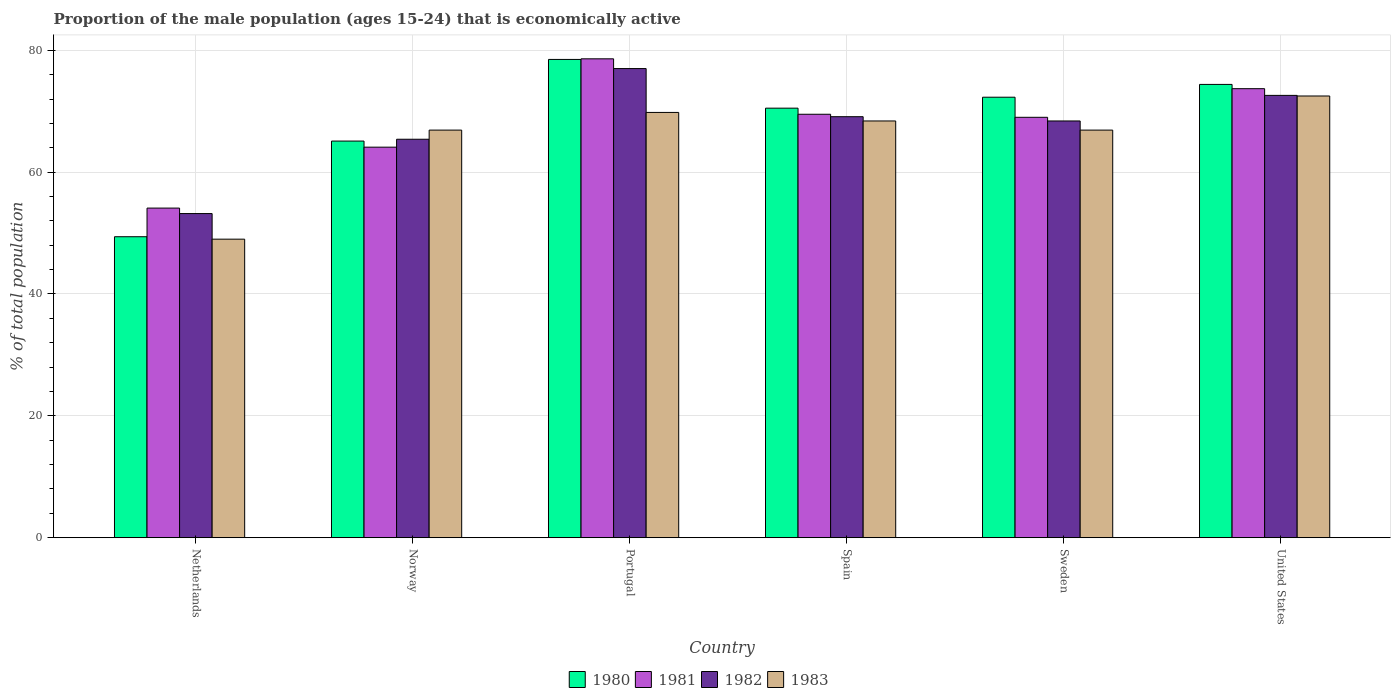How many bars are there on the 1st tick from the right?
Make the answer very short. 4. What is the label of the 3rd group of bars from the left?
Offer a very short reply. Portugal. In how many cases, is the number of bars for a given country not equal to the number of legend labels?
Ensure brevity in your answer.  0. What is the proportion of the male population that is economically active in 1980 in Sweden?
Ensure brevity in your answer.  72.3. Across all countries, what is the maximum proportion of the male population that is economically active in 1982?
Make the answer very short. 77. Across all countries, what is the minimum proportion of the male population that is economically active in 1983?
Your answer should be very brief. 49. In which country was the proportion of the male population that is economically active in 1982 maximum?
Your answer should be compact. Portugal. What is the total proportion of the male population that is economically active in 1980 in the graph?
Your answer should be compact. 410.2. What is the difference between the proportion of the male population that is economically active in 1983 in Spain and that in United States?
Your answer should be compact. -4.1. What is the difference between the proportion of the male population that is economically active in 1980 in Sweden and the proportion of the male population that is economically active in 1982 in Norway?
Your answer should be very brief. 6.9. What is the average proportion of the male population that is economically active in 1982 per country?
Ensure brevity in your answer.  67.62. What is the difference between the proportion of the male population that is economically active of/in 1983 and proportion of the male population that is economically active of/in 1981 in Netherlands?
Make the answer very short. -5.1. What is the ratio of the proportion of the male population that is economically active in 1981 in Norway to that in Sweden?
Offer a terse response. 0.93. What is the difference between the highest and the second highest proportion of the male population that is economically active in 1980?
Your answer should be compact. -2.1. What is the difference between the highest and the lowest proportion of the male population that is economically active in 1983?
Your answer should be very brief. 23.5. In how many countries, is the proportion of the male population that is economically active in 1980 greater than the average proportion of the male population that is economically active in 1980 taken over all countries?
Ensure brevity in your answer.  4. Is the sum of the proportion of the male population that is economically active in 1981 in Norway and Spain greater than the maximum proportion of the male population that is economically active in 1982 across all countries?
Your response must be concise. Yes. Is it the case that in every country, the sum of the proportion of the male population that is economically active in 1981 and proportion of the male population that is economically active in 1982 is greater than the sum of proportion of the male population that is economically active in 1980 and proportion of the male population that is economically active in 1983?
Provide a short and direct response. No. What does the 1st bar from the right in United States represents?
Your answer should be very brief. 1983. Is it the case that in every country, the sum of the proportion of the male population that is economically active in 1982 and proportion of the male population that is economically active in 1983 is greater than the proportion of the male population that is economically active in 1980?
Your answer should be very brief. Yes. How many bars are there?
Your answer should be compact. 24. Are all the bars in the graph horizontal?
Your answer should be very brief. No. What is the difference between two consecutive major ticks on the Y-axis?
Your answer should be compact. 20. Are the values on the major ticks of Y-axis written in scientific E-notation?
Make the answer very short. No. Does the graph contain any zero values?
Ensure brevity in your answer.  No. Does the graph contain grids?
Ensure brevity in your answer.  Yes. Where does the legend appear in the graph?
Offer a very short reply. Bottom center. How many legend labels are there?
Make the answer very short. 4. What is the title of the graph?
Give a very brief answer. Proportion of the male population (ages 15-24) that is economically active. What is the label or title of the Y-axis?
Your answer should be very brief. % of total population. What is the % of total population of 1980 in Netherlands?
Your answer should be compact. 49.4. What is the % of total population in 1981 in Netherlands?
Ensure brevity in your answer.  54.1. What is the % of total population in 1982 in Netherlands?
Give a very brief answer. 53.2. What is the % of total population of 1980 in Norway?
Ensure brevity in your answer.  65.1. What is the % of total population of 1981 in Norway?
Your response must be concise. 64.1. What is the % of total population in 1982 in Norway?
Your response must be concise. 65.4. What is the % of total population in 1983 in Norway?
Your answer should be compact. 66.9. What is the % of total population of 1980 in Portugal?
Your response must be concise. 78.5. What is the % of total population of 1981 in Portugal?
Offer a terse response. 78.6. What is the % of total population of 1983 in Portugal?
Offer a terse response. 69.8. What is the % of total population of 1980 in Spain?
Your answer should be compact. 70.5. What is the % of total population of 1981 in Spain?
Your answer should be very brief. 69.5. What is the % of total population of 1982 in Spain?
Offer a very short reply. 69.1. What is the % of total population of 1983 in Spain?
Offer a very short reply. 68.4. What is the % of total population of 1980 in Sweden?
Provide a succinct answer. 72.3. What is the % of total population of 1982 in Sweden?
Give a very brief answer. 68.4. What is the % of total population in 1983 in Sweden?
Offer a terse response. 66.9. What is the % of total population in 1980 in United States?
Make the answer very short. 74.4. What is the % of total population of 1981 in United States?
Make the answer very short. 73.7. What is the % of total population of 1982 in United States?
Make the answer very short. 72.6. What is the % of total population of 1983 in United States?
Your response must be concise. 72.5. Across all countries, what is the maximum % of total population in 1980?
Your answer should be very brief. 78.5. Across all countries, what is the maximum % of total population of 1981?
Offer a terse response. 78.6. Across all countries, what is the maximum % of total population in 1983?
Your answer should be compact. 72.5. Across all countries, what is the minimum % of total population in 1980?
Your answer should be very brief. 49.4. Across all countries, what is the minimum % of total population in 1981?
Your answer should be compact. 54.1. Across all countries, what is the minimum % of total population in 1982?
Your answer should be very brief. 53.2. Across all countries, what is the minimum % of total population in 1983?
Provide a succinct answer. 49. What is the total % of total population of 1980 in the graph?
Offer a terse response. 410.2. What is the total % of total population in 1981 in the graph?
Provide a succinct answer. 409. What is the total % of total population in 1982 in the graph?
Provide a succinct answer. 405.7. What is the total % of total population in 1983 in the graph?
Your answer should be very brief. 393.5. What is the difference between the % of total population in 1980 in Netherlands and that in Norway?
Provide a succinct answer. -15.7. What is the difference between the % of total population in 1981 in Netherlands and that in Norway?
Your response must be concise. -10. What is the difference between the % of total population of 1982 in Netherlands and that in Norway?
Your answer should be compact. -12.2. What is the difference between the % of total population of 1983 in Netherlands and that in Norway?
Your answer should be very brief. -17.9. What is the difference between the % of total population of 1980 in Netherlands and that in Portugal?
Make the answer very short. -29.1. What is the difference between the % of total population of 1981 in Netherlands and that in Portugal?
Keep it short and to the point. -24.5. What is the difference between the % of total population of 1982 in Netherlands and that in Portugal?
Make the answer very short. -23.8. What is the difference between the % of total population in 1983 in Netherlands and that in Portugal?
Give a very brief answer. -20.8. What is the difference between the % of total population of 1980 in Netherlands and that in Spain?
Make the answer very short. -21.1. What is the difference between the % of total population in 1981 in Netherlands and that in Spain?
Ensure brevity in your answer.  -15.4. What is the difference between the % of total population in 1982 in Netherlands and that in Spain?
Offer a terse response. -15.9. What is the difference between the % of total population in 1983 in Netherlands and that in Spain?
Give a very brief answer. -19.4. What is the difference between the % of total population of 1980 in Netherlands and that in Sweden?
Give a very brief answer. -22.9. What is the difference between the % of total population of 1981 in Netherlands and that in Sweden?
Your answer should be compact. -14.9. What is the difference between the % of total population in 1982 in Netherlands and that in Sweden?
Give a very brief answer. -15.2. What is the difference between the % of total population of 1983 in Netherlands and that in Sweden?
Your answer should be very brief. -17.9. What is the difference between the % of total population of 1980 in Netherlands and that in United States?
Your answer should be very brief. -25. What is the difference between the % of total population of 1981 in Netherlands and that in United States?
Your answer should be compact. -19.6. What is the difference between the % of total population of 1982 in Netherlands and that in United States?
Give a very brief answer. -19.4. What is the difference between the % of total population in 1983 in Netherlands and that in United States?
Keep it short and to the point. -23.5. What is the difference between the % of total population of 1981 in Norway and that in Portugal?
Your answer should be compact. -14.5. What is the difference between the % of total population in 1980 in Norway and that in Spain?
Your answer should be very brief. -5.4. What is the difference between the % of total population of 1981 in Norway and that in Spain?
Provide a short and direct response. -5.4. What is the difference between the % of total population of 1982 in Norway and that in Spain?
Ensure brevity in your answer.  -3.7. What is the difference between the % of total population of 1983 in Norway and that in Spain?
Offer a very short reply. -1.5. What is the difference between the % of total population in 1981 in Norway and that in Sweden?
Your answer should be compact. -4.9. What is the difference between the % of total population in 1980 in Norway and that in United States?
Provide a succinct answer. -9.3. What is the difference between the % of total population in 1983 in Norway and that in United States?
Offer a very short reply. -5.6. What is the difference between the % of total population of 1981 in Portugal and that in Spain?
Your answer should be very brief. 9.1. What is the difference between the % of total population of 1983 in Portugal and that in Spain?
Your answer should be compact. 1.4. What is the difference between the % of total population of 1981 in Portugal and that in Sweden?
Make the answer very short. 9.6. What is the difference between the % of total population of 1982 in Portugal and that in Sweden?
Give a very brief answer. 8.6. What is the difference between the % of total population in 1980 in Portugal and that in United States?
Your answer should be very brief. 4.1. What is the difference between the % of total population of 1981 in Portugal and that in United States?
Make the answer very short. 4.9. What is the difference between the % of total population in 1982 in Portugal and that in United States?
Keep it short and to the point. 4.4. What is the difference between the % of total population in 1980 in Spain and that in Sweden?
Your answer should be compact. -1.8. What is the difference between the % of total population in 1983 in Spain and that in Sweden?
Your answer should be compact. 1.5. What is the difference between the % of total population in 1982 in Sweden and that in United States?
Give a very brief answer. -4.2. What is the difference between the % of total population of 1983 in Sweden and that in United States?
Provide a short and direct response. -5.6. What is the difference between the % of total population of 1980 in Netherlands and the % of total population of 1981 in Norway?
Give a very brief answer. -14.7. What is the difference between the % of total population of 1980 in Netherlands and the % of total population of 1983 in Norway?
Your response must be concise. -17.5. What is the difference between the % of total population of 1981 in Netherlands and the % of total population of 1983 in Norway?
Your answer should be compact. -12.8. What is the difference between the % of total population in 1982 in Netherlands and the % of total population in 1983 in Norway?
Provide a succinct answer. -13.7. What is the difference between the % of total population in 1980 in Netherlands and the % of total population in 1981 in Portugal?
Your answer should be very brief. -29.2. What is the difference between the % of total population of 1980 in Netherlands and the % of total population of 1982 in Portugal?
Offer a very short reply. -27.6. What is the difference between the % of total population in 1980 in Netherlands and the % of total population in 1983 in Portugal?
Provide a short and direct response. -20.4. What is the difference between the % of total population of 1981 in Netherlands and the % of total population of 1982 in Portugal?
Offer a terse response. -22.9. What is the difference between the % of total population of 1981 in Netherlands and the % of total population of 1983 in Portugal?
Give a very brief answer. -15.7. What is the difference between the % of total population in 1982 in Netherlands and the % of total population in 1983 in Portugal?
Give a very brief answer. -16.6. What is the difference between the % of total population in 1980 in Netherlands and the % of total population in 1981 in Spain?
Your answer should be compact. -20.1. What is the difference between the % of total population in 1980 in Netherlands and the % of total population in 1982 in Spain?
Your answer should be compact. -19.7. What is the difference between the % of total population of 1981 in Netherlands and the % of total population of 1982 in Spain?
Keep it short and to the point. -15. What is the difference between the % of total population of 1981 in Netherlands and the % of total population of 1983 in Spain?
Offer a very short reply. -14.3. What is the difference between the % of total population of 1982 in Netherlands and the % of total population of 1983 in Spain?
Provide a succinct answer. -15.2. What is the difference between the % of total population in 1980 in Netherlands and the % of total population in 1981 in Sweden?
Give a very brief answer. -19.6. What is the difference between the % of total population of 1980 in Netherlands and the % of total population of 1982 in Sweden?
Offer a very short reply. -19. What is the difference between the % of total population in 1980 in Netherlands and the % of total population in 1983 in Sweden?
Make the answer very short. -17.5. What is the difference between the % of total population of 1981 in Netherlands and the % of total population of 1982 in Sweden?
Your answer should be very brief. -14.3. What is the difference between the % of total population of 1981 in Netherlands and the % of total population of 1983 in Sweden?
Give a very brief answer. -12.8. What is the difference between the % of total population of 1982 in Netherlands and the % of total population of 1983 in Sweden?
Give a very brief answer. -13.7. What is the difference between the % of total population of 1980 in Netherlands and the % of total population of 1981 in United States?
Provide a succinct answer. -24.3. What is the difference between the % of total population of 1980 in Netherlands and the % of total population of 1982 in United States?
Provide a short and direct response. -23.2. What is the difference between the % of total population of 1980 in Netherlands and the % of total population of 1983 in United States?
Keep it short and to the point. -23.1. What is the difference between the % of total population of 1981 in Netherlands and the % of total population of 1982 in United States?
Provide a succinct answer. -18.5. What is the difference between the % of total population of 1981 in Netherlands and the % of total population of 1983 in United States?
Offer a very short reply. -18.4. What is the difference between the % of total population of 1982 in Netherlands and the % of total population of 1983 in United States?
Offer a very short reply. -19.3. What is the difference between the % of total population of 1980 in Norway and the % of total population of 1982 in Portugal?
Offer a terse response. -11.9. What is the difference between the % of total population of 1980 in Norway and the % of total population of 1983 in Portugal?
Your answer should be compact. -4.7. What is the difference between the % of total population of 1981 in Norway and the % of total population of 1982 in Portugal?
Offer a terse response. -12.9. What is the difference between the % of total population in 1980 in Norway and the % of total population in 1982 in Spain?
Your response must be concise. -4. What is the difference between the % of total population in 1980 in Norway and the % of total population in 1983 in Spain?
Ensure brevity in your answer.  -3.3. What is the difference between the % of total population in 1981 in Norway and the % of total population in 1983 in Spain?
Offer a terse response. -4.3. What is the difference between the % of total population in 1982 in Norway and the % of total population in 1983 in Spain?
Ensure brevity in your answer.  -3. What is the difference between the % of total population in 1981 in Norway and the % of total population in 1982 in Sweden?
Keep it short and to the point. -4.3. What is the difference between the % of total population of 1981 in Norway and the % of total population of 1983 in Sweden?
Your answer should be very brief. -2.8. What is the difference between the % of total population in 1980 in Norway and the % of total population in 1981 in United States?
Your answer should be very brief. -8.6. What is the difference between the % of total population in 1980 in Norway and the % of total population in 1983 in United States?
Ensure brevity in your answer.  -7.4. What is the difference between the % of total population of 1982 in Norway and the % of total population of 1983 in United States?
Give a very brief answer. -7.1. What is the difference between the % of total population of 1980 in Portugal and the % of total population of 1981 in Spain?
Provide a succinct answer. 9. What is the difference between the % of total population of 1980 in Portugal and the % of total population of 1982 in Spain?
Provide a succinct answer. 9.4. What is the difference between the % of total population of 1981 in Portugal and the % of total population of 1982 in Spain?
Your answer should be very brief. 9.5. What is the difference between the % of total population of 1980 in Portugal and the % of total population of 1983 in Sweden?
Make the answer very short. 11.6. What is the difference between the % of total population of 1981 in Portugal and the % of total population of 1983 in Sweden?
Offer a terse response. 11.7. What is the difference between the % of total population in 1980 in Portugal and the % of total population in 1981 in United States?
Ensure brevity in your answer.  4.8. What is the difference between the % of total population of 1980 in Portugal and the % of total population of 1982 in United States?
Give a very brief answer. 5.9. What is the difference between the % of total population of 1980 in Portugal and the % of total population of 1983 in United States?
Give a very brief answer. 6. What is the difference between the % of total population of 1981 in Portugal and the % of total population of 1982 in United States?
Provide a short and direct response. 6. What is the difference between the % of total population of 1981 in Portugal and the % of total population of 1983 in United States?
Offer a very short reply. 6.1. What is the difference between the % of total population of 1980 in Spain and the % of total population of 1983 in Sweden?
Your response must be concise. 3.6. What is the difference between the % of total population in 1981 in Spain and the % of total population in 1982 in Sweden?
Make the answer very short. 1.1. What is the difference between the % of total population in 1980 in Spain and the % of total population in 1983 in United States?
Offer a terse response. -2. What is the difference between the % of total population in 1980 in Sweden and the % of total population in 1982 in United States?
Your answer should be very brief. -0.3. What is the difference between the % of total population of 1980 in Sweden and the % of total population of 1983 in United States?
Your response must be concise. -0.2. What is the difference between the % of total population of 1981 in Sweden and the % of total population of 1982 in United States?
Offer a terse response. -3.6. What is the average % of total population in 1980 per country?
Keep it short and to the point. 68.37. What is the average % of total population of 1981 per country?
Your answer should be very brief. 68.17. What is the average % of total population in 1982 per country?
Keep it short and to the point. 67.62. What is the average % of total population in 1983 per country?
Offer a very short reply. 65.58. What is the difference between the % of total population of 1980 and % of total population of 1982 in Netherlands?
Offer a terse response. -3.8. What is the difference between the % of total population in 1982 and % of total population in 1983 in Netherlands?
Offer a terse response. 4.2. What is the difference between the % of total population of 1980 and % of total population of 1981 in Norway?
Keep it short and to the point. 1. What is the difference between the % of total population in 1980 and % of total population in 1983 in Norway?
Provide a succinct answer. -1.8. What is the difference between the % of total population in 1981 and % of total population in 1983 in Norway?
Offer a terse response. -2.8. What is the difference between the % of total population of 1982 and % of total population of 1983 in Norway?
Provide a succinct answer. -1.5. What is the difference between the % of total population of 1980 and % of total population of 1981 in Portugal?
Your answer should be compact. -0.1. What is the difference between the % of total population in 1980 and % of total population in 1982 in Portugal?
Offer a very short reply. 1.5. What is the difference between the % of total population of 1981 and % of total population of 1982 in Portugal?
Provide a short and direct response. 1.6. What is the difference between the % of total population in 1981 and % of total population in 1983 in Portugal?
Make the answer very short. 8.8. What is the difference between the % of total population in 1982 and % of total population in 1983 in Portugal?
Provide a short and direct response. 7.2. What is the difference between the % of total population in 1980 and % of total population in 1982 in Spain?
Your answer should be compact. 1.4. What is the difference between the % of total population of 1980 and % of total population of 1983 in Spain?
Make the answer very short. 2.1. What is the difference between the % of total population of 1981 and % of total population of 1982 in Spain?
Provide a short and direct response. 0.4. What is the difference between the % of total population of 1982 and % of total population of 1983 in Spain?
Provide a succinct answer. 0.7. What is the difference between the % of total population of 1980 and % of total population of 1981 in Sweden?
Ensure brevity in your answer.  3.3. What is the difference between the % of total population in 1980 and % of total population in 1982 in Sweden?
Your answer should be very brief. 3.9. What is the difference between the % of total population in 1981 and % of total population in 1982 in United States?
Your answer should be very brief. 1.1. What is the ratio of the % of total population of 1980 in Netherlands to that in Norway?
Make the answer very short. 0.76. What is the ratio of the % of total population of 1981 in Netherlands to that in Norway?
Give a very brief answer. 0.84. What is the ratio of the % of total population in 1982 in Netherlands to that in Norway?
Keep it short and to the point. 0.81. What is the ratio of the % of total population in 1983 in Netherlands to that in Norway?
Your answer should be very brief. 0.73. What is the ratio of the % of total population of 1980 in Netherlands to that in Portugal?
Give a very brief answer. 0.63. What is the ratio of the % of total population of 1981 in Netherlands to that in Portugal?
Your response must be concise. 0.69. What is the ratio of the % of total population in 1982 in Netherlands to that in Portugal?
Ensure brevity in your answer.  0.69. What is the ratio of the % of total population in 1983 in Netherlands to that in Portugal?
Your response must be concise. 0.7. What is the ratio of the % of total population in 1980 in Netherlands to that in Spain?
Provide a short and direct response. 0.7. What is the ratio of the % of total population in 1981 in Netherlands to that in Spain?
Keep it short and to the point. 0.78. What is the ratio of the % of total population in 1982 in Netherlands to that in Spain?
Your response must be concise. 0.77. What is the ratio of the % of total population of 1983 in Netherlands to that in Spain?
Your response must be concise. 0.72. What is the ratio of the % of total population of 1980 in Netherlands to that in Sweden?
Ensure brevity in your answer.  0.68. What is the ratio of the % of total population of 1981 in Netherlands to that in Sweden?
Your answer should be compact. 0.78. What is the ratio of the % of total population of 1983 in Netherlands to that in Sweden?
Offer a very short reply. 0.73. What is the ratio of the % of total population in 1980 in Netherlands to that in United States?
Provide a succinct answer. 0.66. What is the ratio of the % of total population of 1981 in Netherlands to that in United States?
Make the answer very short. 0.73. What is the ratio of the % of total population in 1982 in Netherlands to that in United States?
Offer a very short reply. 0.73. What is the ratio of the % of total population in 1983 in Netherlands to that in United States?
Make the answer very short. 0.68. What is the ratio of the % of total population of 1980 in Norway to that in Portugal?
Offer a terse response. 0.83. What is the ratio of the % of total population of 1981 in Norway to that in Portugal?
Provide a succinct answer. 0.82. What is the ratio of the % of total population of 1982 in Norway to that in Portugal?
Offer a terse response. 0.85. What is the ratio of the % of total population of 1983 in Norway to that in Portugal?
Your answer should be compact. 0.96. What is the ratio of the % of total population in 1980 in Norway to that in Spain?
Provide a short and direct response. 0.92. What is the ratio of the % of total population of 1981 in Norway to that in Spain?
Provide a succinct answer. 0.92. What is the ratio of the % of total population in 1982 in Norway to that in Spain?
Your answer should be very brief. 0.95. What is the ratio of the % of total population of 1983 in Norway to that in Spain?
Offer a very short reply. 0.98. What is the ratio of the % of total population in 1980 in Norway to that in Sweden?
Your response must be concise. 0.9. What is the ratio of the % of total population in 1981 in Norway to that in Sweden?
Give a very brief answer. 0.93. What is the ratio of the % of total population in 1982 in Norway to that in Sweden?
Offer a terse response. 0.96. What is the ratio of the % of total population of 1980 in Norway to that in United States?
Give a very brief answer. 0.88. What is the ratio of the % of total population of 1981 in Norway to that in United States?
Offer a very short reply. 0.87. What is the ratio of the % of total population of 1982 in Norway to that in United States?
Provide a short and direct response. 0.9. What is the ratio of the % of total population in 1983 in Norway to that in United States?
Ensure brevity in your answer.  0.92. What is the ratio of the % of total population of 1980 in Portugal to that in Spain?
Ensure brevity in your answer.  1.11. What is the ratio of the % of total population in 1981 in Portugal to that in Spain?
Your answer should be compact. 1.13. What is the ratio of the % of total population of 1982 in Portugal to that in Spain?
Provide a succinct answer. 1.11. What is the ratio of the % of total population of 1983 in Portugal to that in Spain?
Your response must be concise. 1.02. What is the ratio of the % of total population of 1980 in Portugal to that in Sweden?
Provide a short and direct response. 1.09. What is the ratio of the % of total population of 1981 in Portugal to that in Sweden?
Your answer should be very brief. 1.14. What is the ratio of the % of total population in 1982 in Portugal to that in Sweden?
Your answer should be compact. 1.13. What is the ratio of the % of total population of 1983 in Portugal to that in Sweden?
Provide a succinct answer. 1.04. What is the ratio of the % of total population of 1980 in Portugal to that in United States?
Provide a succinct answer. 1.06. What is the ratio of the % of total population of 1981 in Portugal to that in United States?
Provide a short and direct response. 1.07. What is the ratio of the % of total population of 1982 in Portugal to that in United States?
Keep it short and to the point. 1.06. What is the ratio of the % of total population in 1983 in Portugal to that in United States?
Provide a succinct answer. 0.96. What is the ratio of the % of total population of 1980 in Spain to that in Sweden?
Offer a terse response. 0.98. What is the ratio of the % of total population of 1981 in Spain to that in Sweden?
Provide a short and direct response. 1.01. What is the ratio of the % of total population of 1982 in Spain to that in Sweden?
Make the answer very short. 1.01. What is the ratio of the % of total population in 1983 in Spain to that in Sweden?
Your answer should be very brief. 1.02. What is the ratio of the % of total population in 1980 in Spain to that in United States?
Offer a very short reply. 0.95. What is the ratio of the % of total population in 1981 in Spain to that in United States?
Ensure brevity in your answer.  0.94. What is the ratio of the % of total population of 1982 in Spain to that in United States?
Your response must be concise. 0.95. What is the ratio of the % of total population of 1983 in Spain to that in United States?
Offer a very short reply. 0.94. What is the ratio of the % of total population in 1980 in Sweden to that in United States?
Provide a short and direct response. 0.97. What is the ratio of the % of total population in 1981 in Sweden to that in United States?
Provide a short and direct response. 0.94. What is the ratio of the % of total population of 1982 in Sweden to that in United States?
Offer a terse response. 0.94. What is the ratio of the % of total population of 1983 in Sweden to that in United States?
Your answer should be compact. 0.92. What is the difference between the highest and the second highest % of total population in 1980?
Your answer should be very brief. 4.1. What is the difference between the highest and the second highest % of total population of 1982?
Your answer should be compact. 4.4. What is the difference between the highest and the second highest % of total population in 1983?
Provide a short and direct response. 2.7. What is the difference between the highest and the lowest % of total population in 1980?
Make the answer very short. 29.1. What is the difference between the highest and the lowest % of total population in 1982?
Ensure brevity in your answer.  23.8. What is the difference between the highest and the lowest % of total population of 1983?
Your response must be concise. 23.5. 